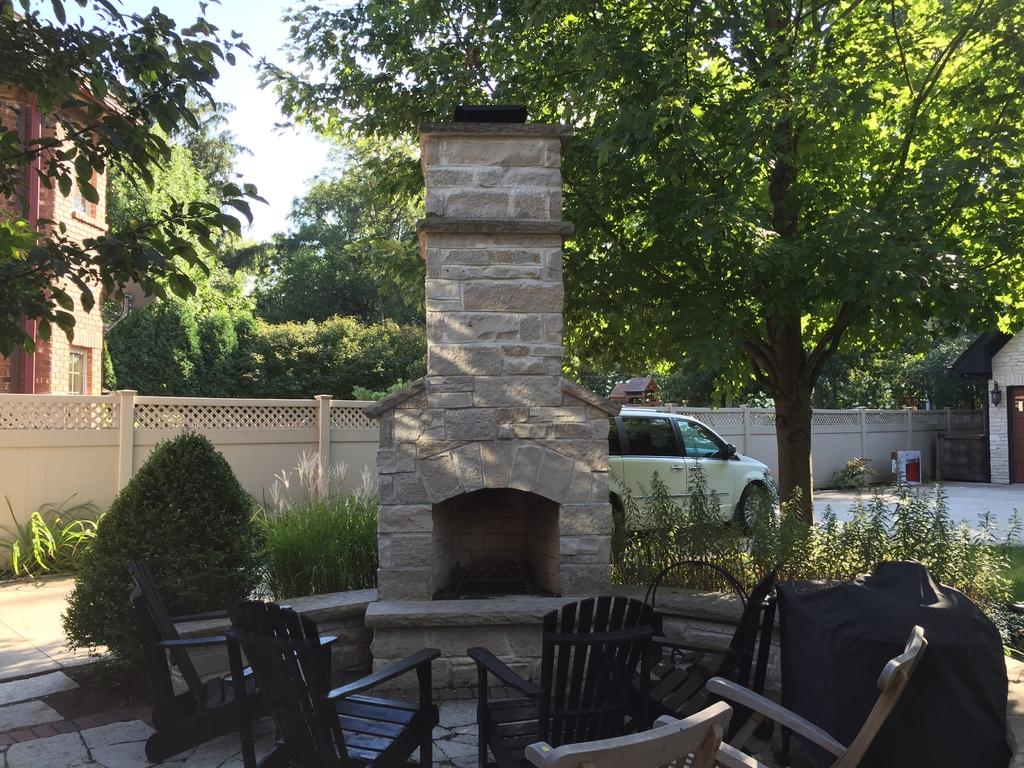Where was the image taken? The image was taken outdoors. What is the weather like in the image? It is sunny in the image. What type of furniture is present in the image? There are chairs and tables in the image. What architectural feature can be seen in the image? There is a pillar in the image. What type of vehicle is visible in the image? There is a car in the image. What type of vegetation is present in the image? There are trees in the image. What is visible in the background of the pillar? The background of the pillar includes a building. What part of the natural environment is visible in the image? The sky is visible in the background of the image. What type of knife is being used to cut the twig in the image? There is no knife or twig present in the image. What is the texture of the tree trunk in the image? There is no tree trunk visible in the image; only trees are mentioned. 